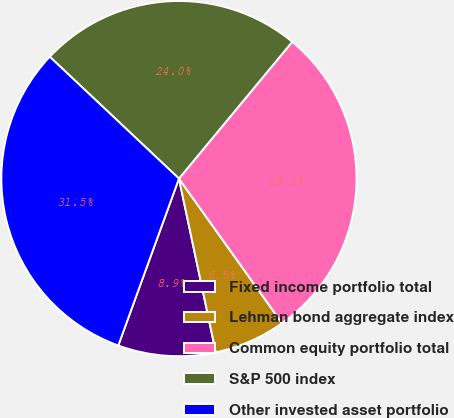Convert chart to OTSL. <chart><loc_0><loc_0><loc_500><loc_500><pie_chart><fcel>Fixed income portfolio total<fcel>Lehman bond aggregate index<fcel>Common equity portfolio total<fcel>S&P 500 index<fcel>Other invested asset portfolio<nl><fcel>8.88%<fcel>6.53%<fcel>29.14%<fcel>23.98%<fcel>31.49%<nl></chart> 